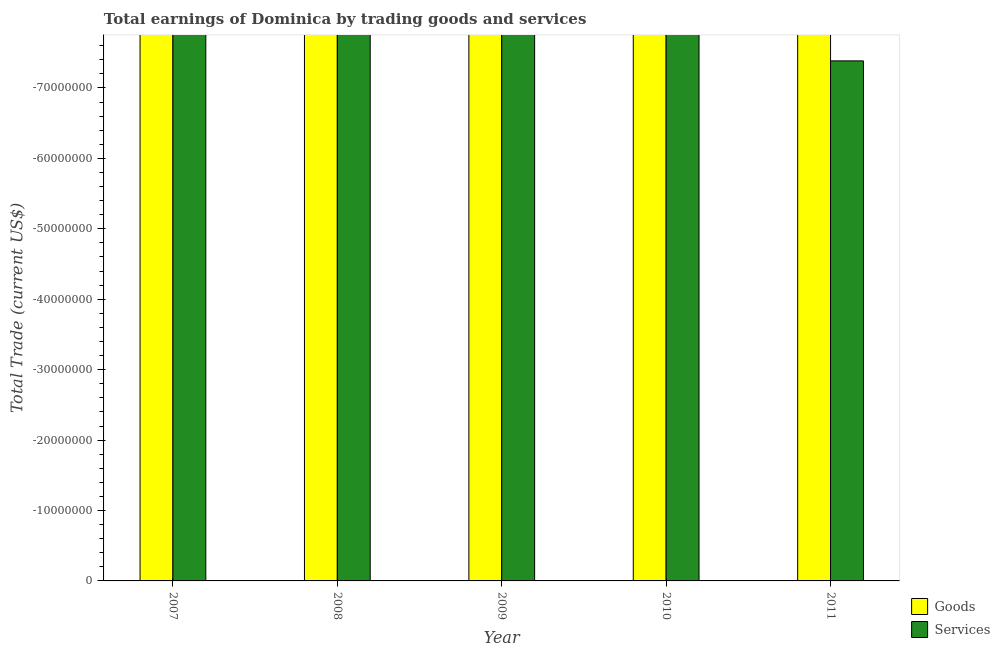Are the number of bars on each tick of the X-axis equal?
Provide a succinct answer. Yes. How many bars are there on the 1st tick from the right?
Give a very brief answer. 0. What is the difference between the amount earned by trading services in 2011 and the amount earned by trading goods in 2010?
Ensure brevity in your answer.  0. What is the average amount earned by trading services per year?
Provide a short and direct response. 0. In how many years, is the amount earned by trading goods greater than -24000000 US$?
Offer a very short reply. 0. How many bars are there?
Provide a short and direct response. 0. What is the difference between two consecutive major ticks on the Y-axis?
Keep it short and to the point. 1.00e+07. Does the graph contain any zero values?
Your answer should be compact. Yes. Does the graph contain grids?
Make the answer very short. No. What is the title of the graph?
Offer a very short reply. Total earnings of Dominica by trading goods and services. What is the label or title of the X-axis?
Provide a succinct answer. Year. What is the label or title of the Y-axis?
Keep it short and to the point. Total Trade (current US$). What is the Total Trade (current US$) in Goods in 2007?
Offer a terse response. 0. What is the Total Trade (current US$) in Services in 2007?
Provide a succinct answer. 0. What is the Total Trade (current US$) of Goods in 2008?
Offer a very short reply. 0. What is the Total Trade (current US$) of Goods in 2009?
Provide a succinct answer. 0. What is the Total Trade (current US$) of Goods in 2011?
Your answer should be very brief. 0. What is the Total Trade (current US$) of Services in 2011?
Keep it short and to the point. 0. What is the total Total Trade (current US$) of Services in the graph?
Provide a short and direct response. 0. What is the average Total Trade (current US$) of Goods per year?
Your answer should be very brief. 0. What is the average Total Trade (current US$) in Services per year?
Offer a very short reply. 0. 